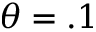<formula> <loc_0><loc_0><loc_500><loc_500>\theta = . 1</formula> 